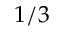Convert formula to latex. <formula><loc_0><loc_0><loc_500><loc_500>1 / 3</formula> 